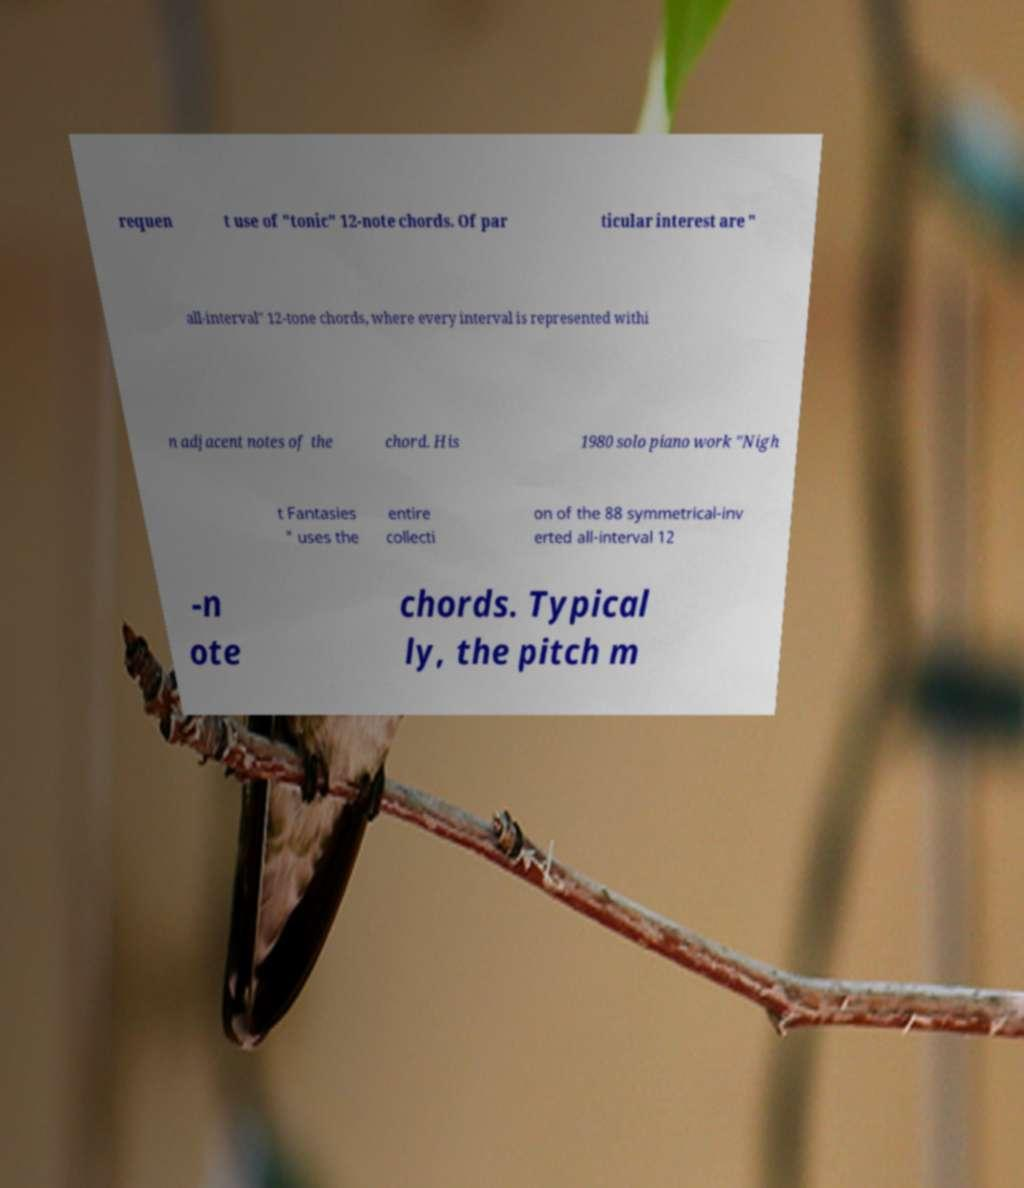What messages or text are displayed in this image? I need them in a readable, typed format. requen t use of "tonic" 12-note chords. Of par ticular interest are " all-interval" 12-tone chords, where every interval is represented withi n adjacent notes of the chord. His 1980 solo piano work "Nigh t Fantasies " uses the entire collecti on of the 88 symmetrical-inv erted all-interval 12 -n ote chords. Typical ly, the pitch m 